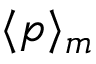Convert formula to latex. <formula><loc_0><loc_0><loc_500><loc_500>\langle p \rangle _ { m }</formula> 